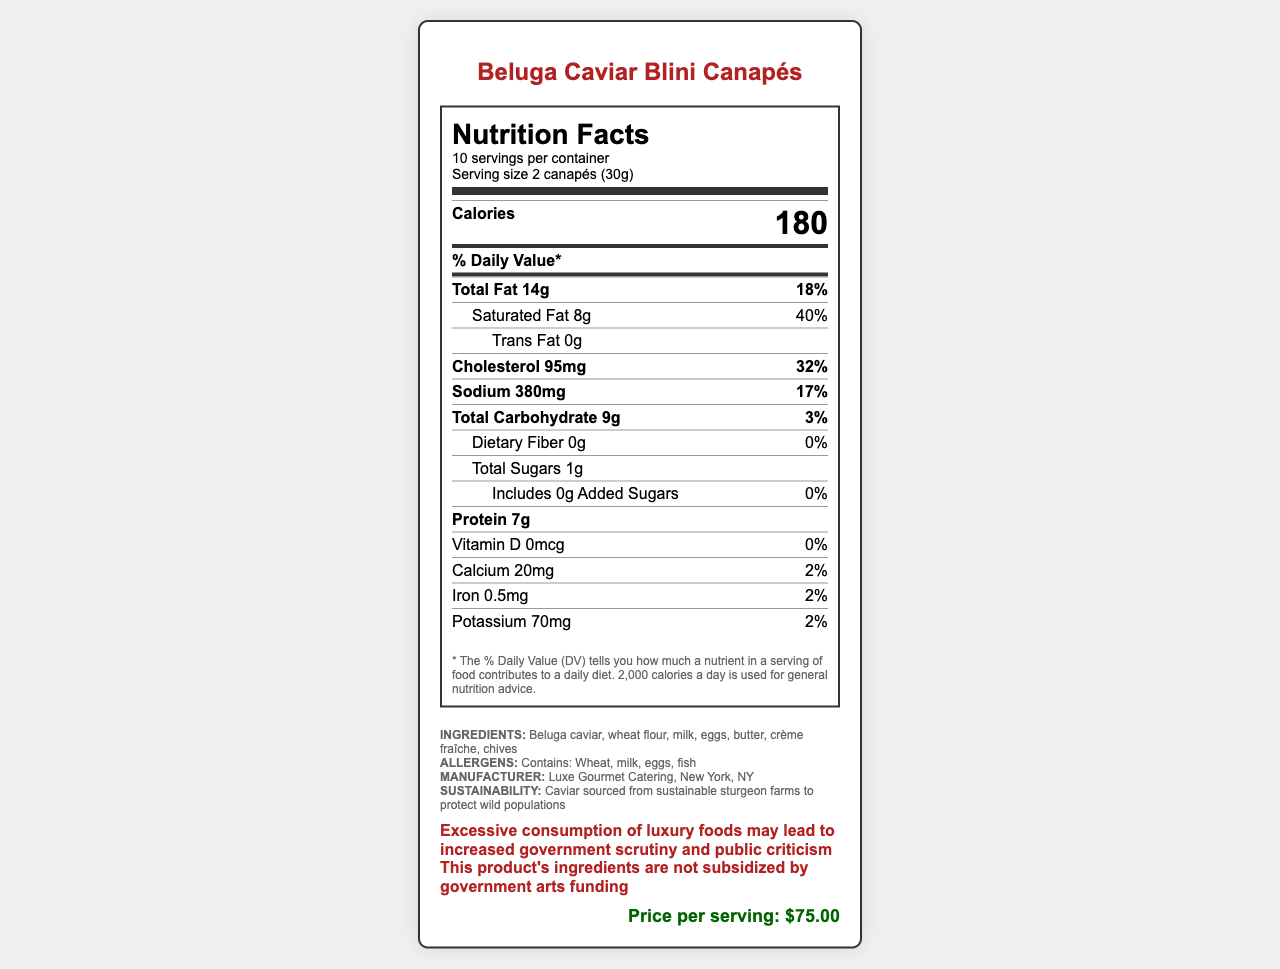what is the serving size for Beluga Caviar Blini Canapés? The serving size is clearly stated as "2 canapés (30g)" in the serving information at the top of the nutrition label.
Answer: 2 canapés (30g) how many calories are in one serving? The document specifies that each serving contains 180 calories.
Answer: 180 how much saturated fat is in a serving and what percentage of the daily value does this represent? The nutritional label shows that a serving contains 8g of saturated fat, which is 40% of the daily value.
Answer: 8g, 40% what allergens are contained in this product? The document lists the allergens as "Contains: Wheat, milk, eggs, fish".
Answer: Wheat, milk, eggs, fish what is the price per serving? The price per serving is listed as $75.00 on the bottom right of the document.
Answer: $75.00 does the product include any added sugars? The nutritional information under total sugars clarifies "Includes 0g Added Sugars."
Answer: No what ingredients are used in Beluga Caviar Blini Canapés? The ingredients list specifies these components.
Answer: Beluga caviar, wheat flour, milk, eggs, butter, crème fraîche, chives how many servings are there per container? A. 5 B. 10 C. 15 D. 20 The document states "10 servings per container" in the serving information.
Answer: B. 10 what is the percentage of the daily value of sodium in one serving? A. 17% B. 32% C. 18% D. 3% The sodium content is listed as 380mg, which is 17% of the daily value.
Answer: A. 17% is excessive consumption of this product linked to any warning? The warning section indicates that "Excessive consumption of luxury foods may lead to increased government scrutiny and public criticism."
Answer: Yes what is the summary of the document? The document comprehensively covers the nutritional makeup, ingredients, health warnings, and additional information about the product and manufacturer.
Answer: The document provides the Nutrition Facts for Beluga Caviar Blini Canapés, highlighting a high calorie count of 180 per serving, and significant amounts of fats, cholesterol, and sodium. It also discusses ingredients, allergens, manufacturer details, and highlights warnings and sustainability practices. how much protein does one serving contain? The protein content per serving is listed as 7g in the nutritional information.
Answer: 7g is the product subsidized by government arts funding? A. Yes B. No C. Partially D. Cannot be determined The taxpayer notice section specifies that the product's ingredients are not subsidized by government arts funding.
Answer: B. No how much total carbohydrate is in one serving and what is its daily value percentage? The total carbohydrate is 9g which is 3% of the daily value.
Answer: 9g, 3% how much potassium does the product contain per serving? The document lists the potassium content as 70mg per serving.
Answer: 70mg how much calcium is in one serving? The calcium content per serving is 20mg as stated in the nutritional information.
Answer: 20mg when was the Beluga Caviar Blini Canapés introduced to the market? The document does not provide any details about the product launch date.
Answer: Not enough information 